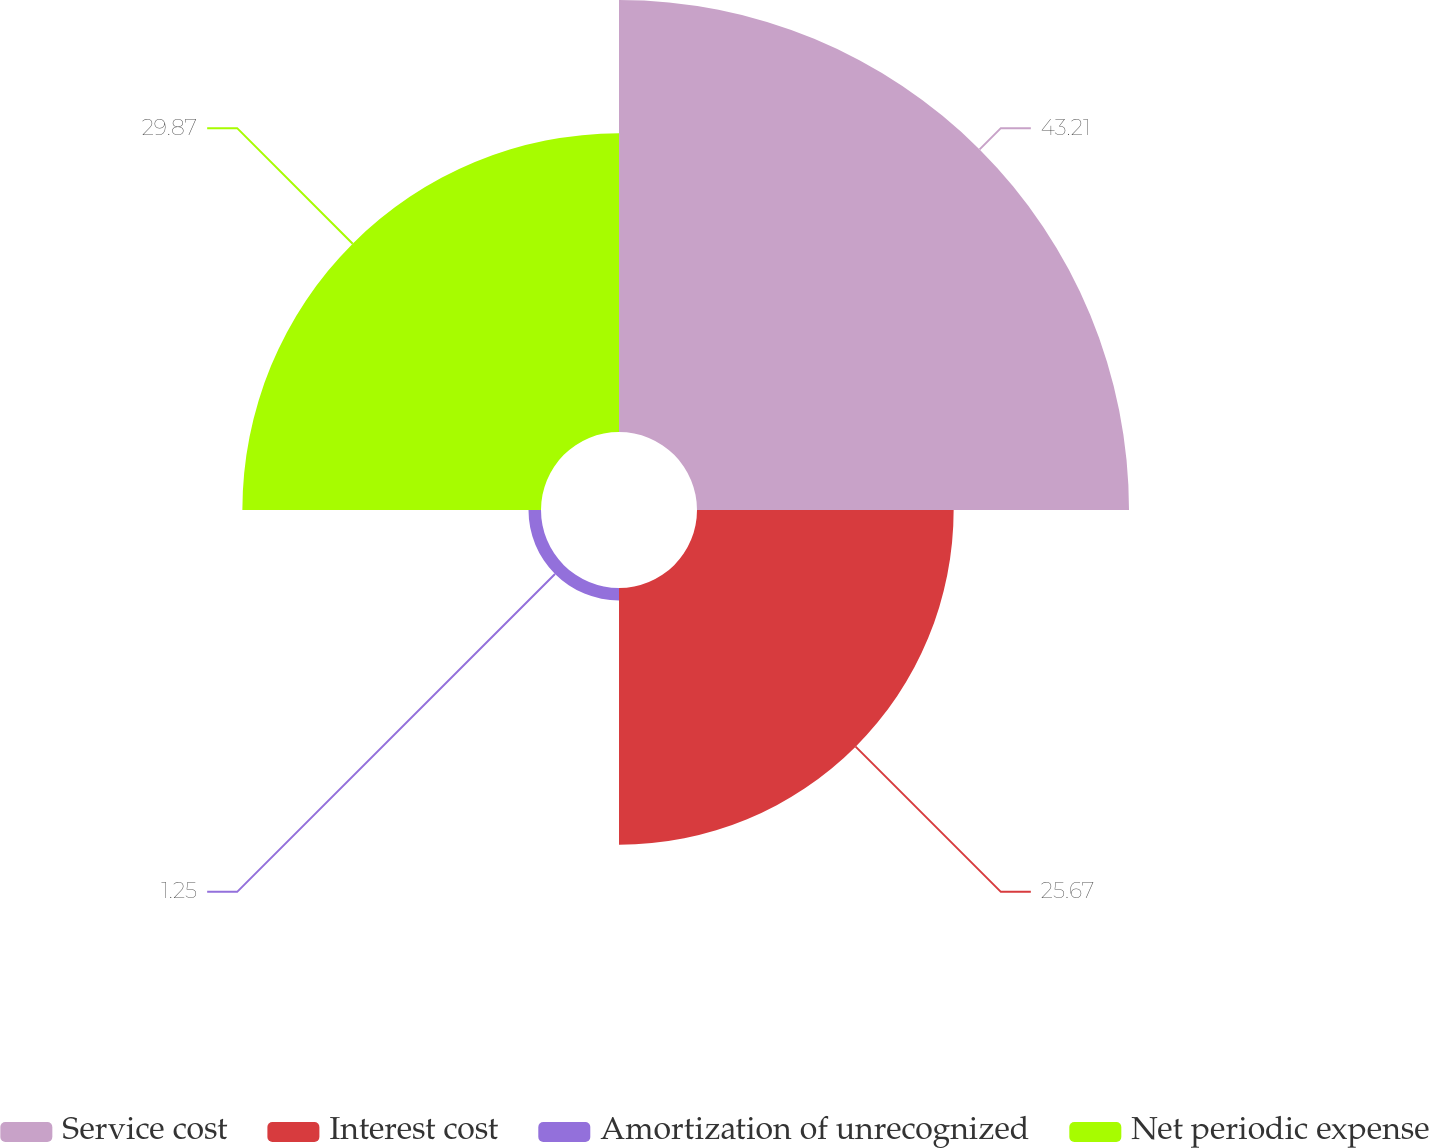Convert chart to OTSL. <chart><loc_0><loc_0><loc_500><loc_500><pie_chart><fcel>Service cost<fcel>Interest cost<fcel>Amortization of unrecognized<fcel>Net periodic expense<nl><fcel>43.21%<fcel>25.67%<fcel>1.25%<fcel>29.87%<nl></chart> 